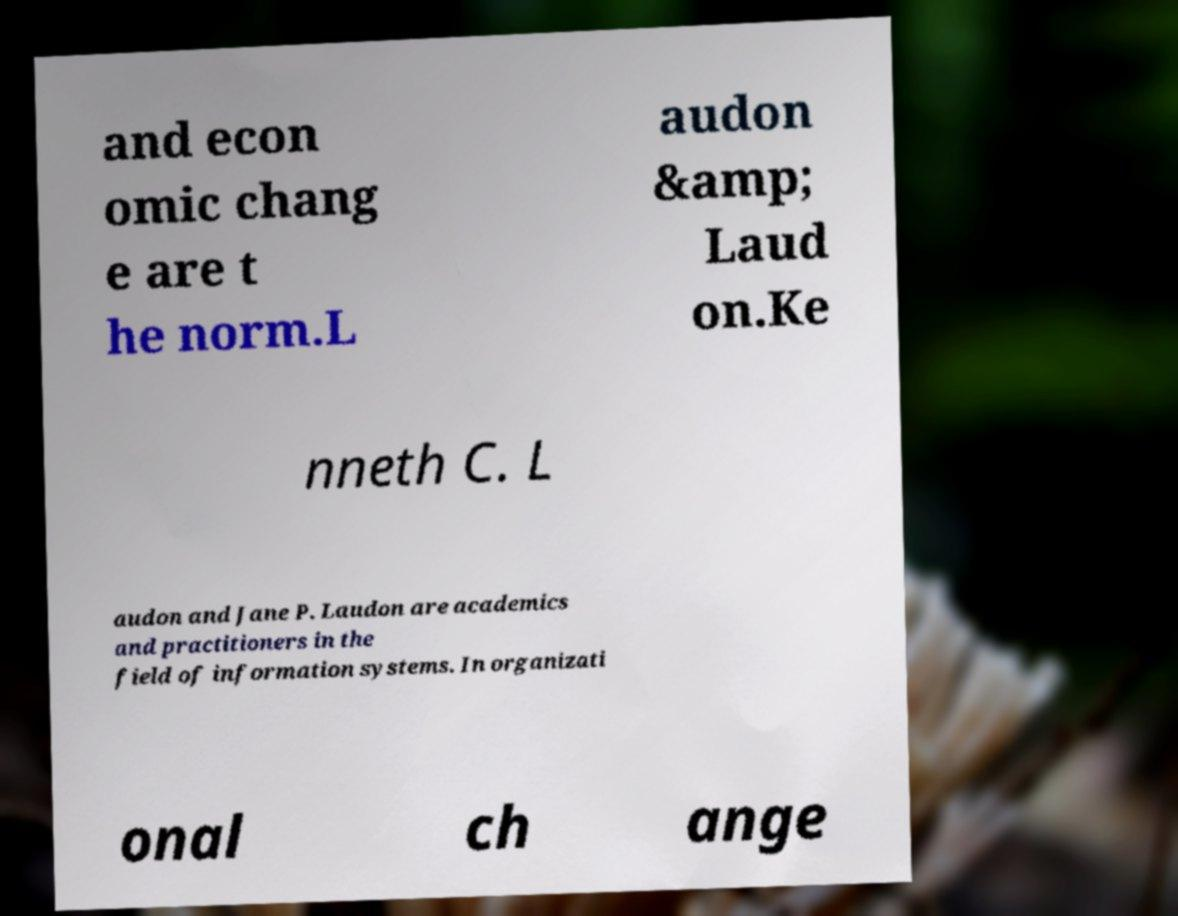Could you assist in decoding the text presented in this image and type it out clearly? and econ omic chang e are t he norm.L audon &amp; Laud on.Ke nneth C. L audon and Jane P. Laudon are academics and practitioners in the field of information systems. In organizati onal ch ange 